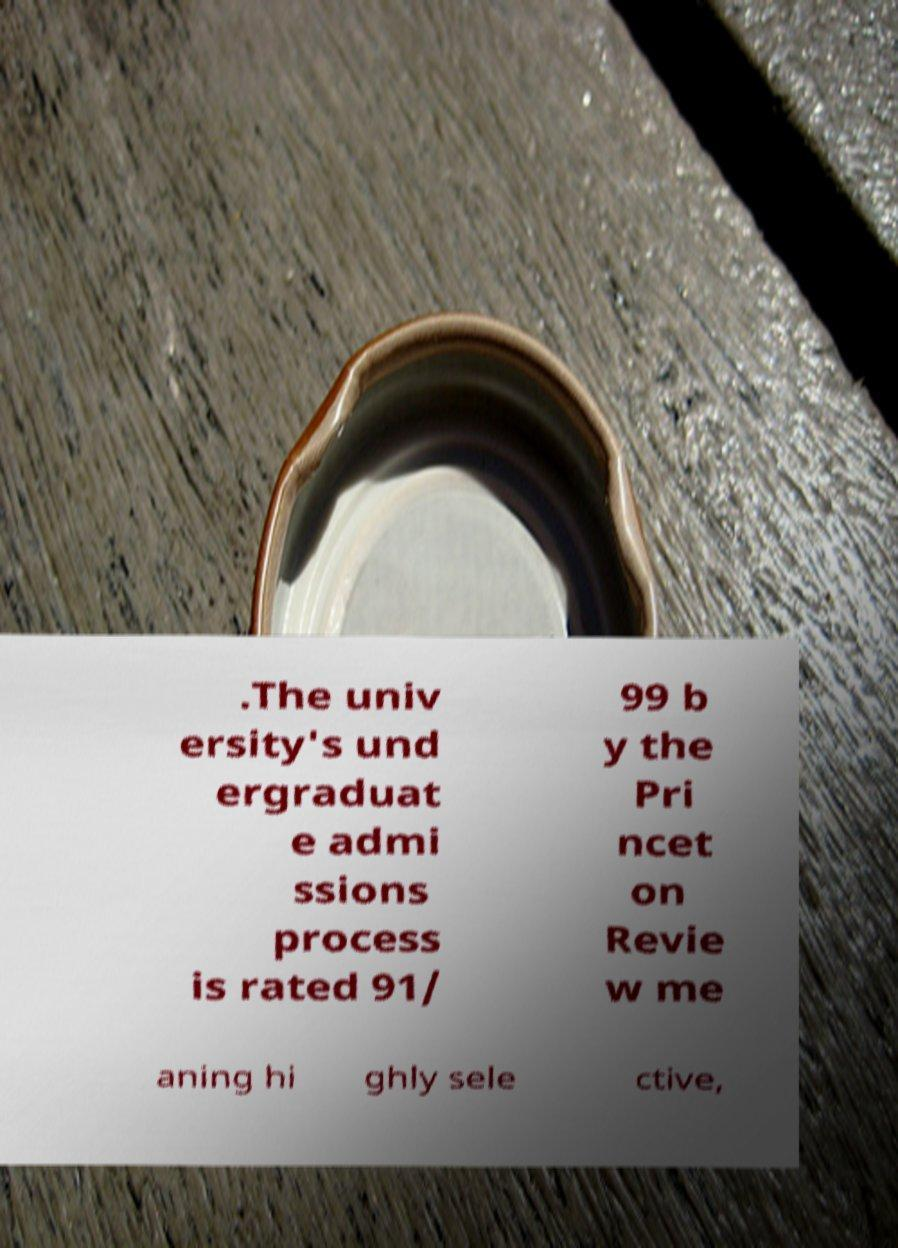What messages or text are displayed in this image? I need them in a readable, typed format. .The univ ersity's und ergraduat e admi ssions process is rated 91/ 99 b y the Pri ncet on Revie w me aning hi ghly sele ctive, 